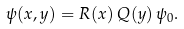<formula> <loc_0><loc_0><loc_500><loc_500>\psi ( x , y ) = R ( x ) \, Q ( y ) \, \psi _ { 0 } .</formula> 